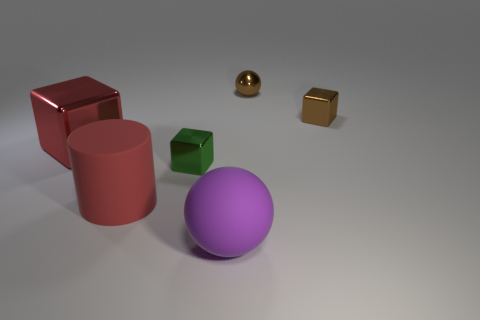Add 1 matte cylinders. How many objects exist? 7 Subtract all balls. How many objects are left? 4 Subtract all tiny red objects. Subtract all large cylinders. How many objects are left? 5 Add 4 small things. How many small things are left? 7 Add 3 tiny objects. How many tiny objects exist? 6 Subtract 0 cyan blocks. How many objects are left? 6 